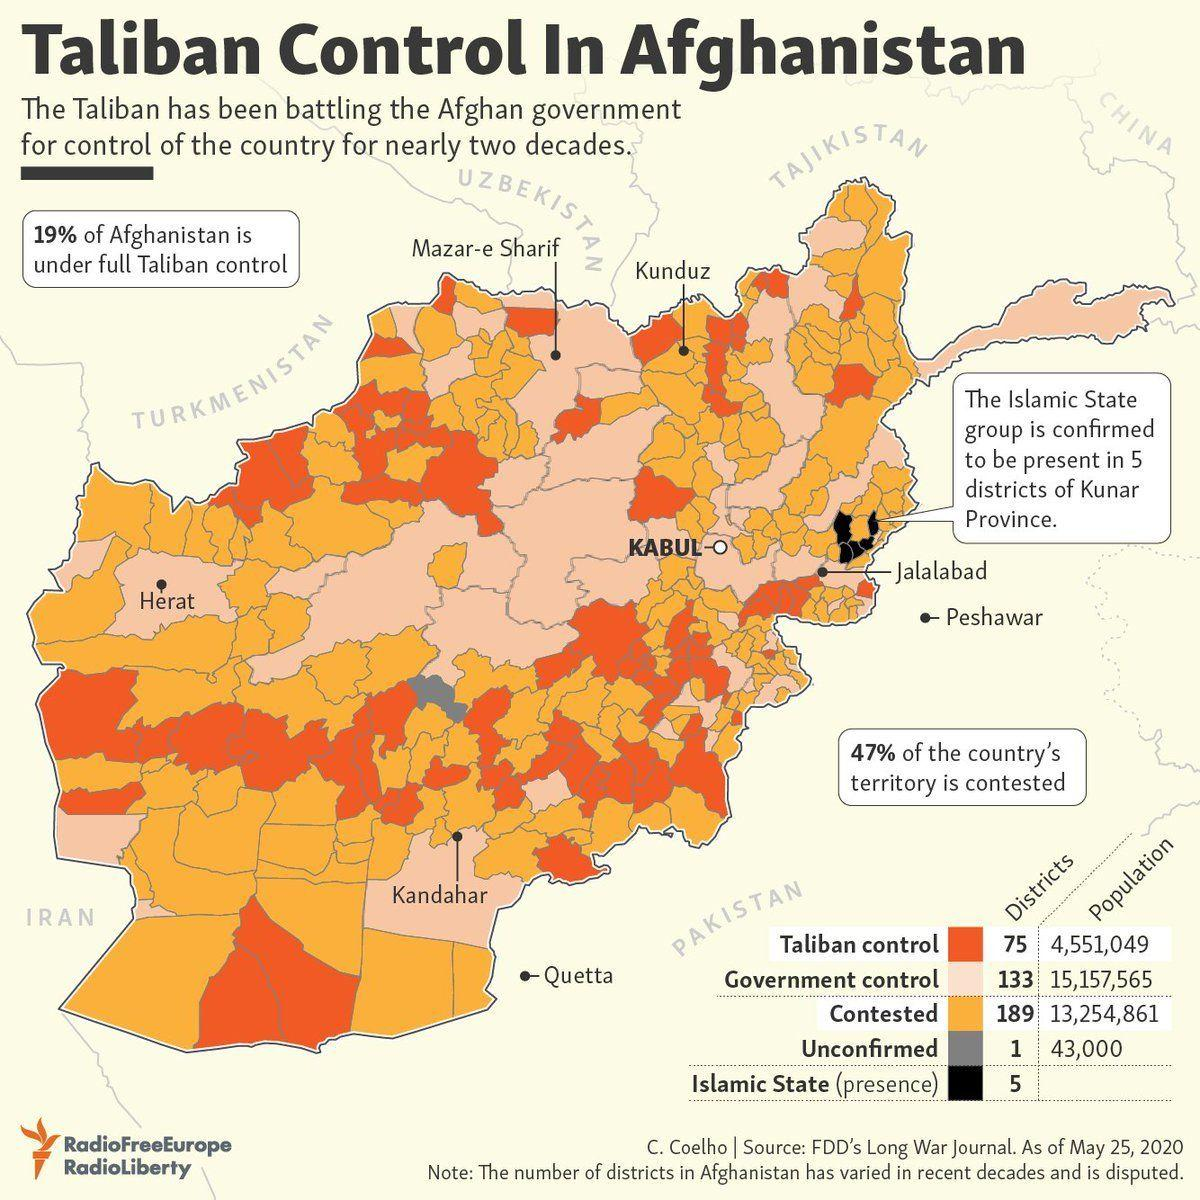Specify some key components in this picture. The city located in the northern region depicted as contested territory in the map is Kunduz. The city of Kabul is located in government control, not contested territory. Mazar-e-Sharif, a city in the northern region, is depicted as being under the control of the government in the map. The city shown on the map that is closest to the area under control of the Islamic State is Jalalabad. The city shown in the map located in the western region is Herat. 